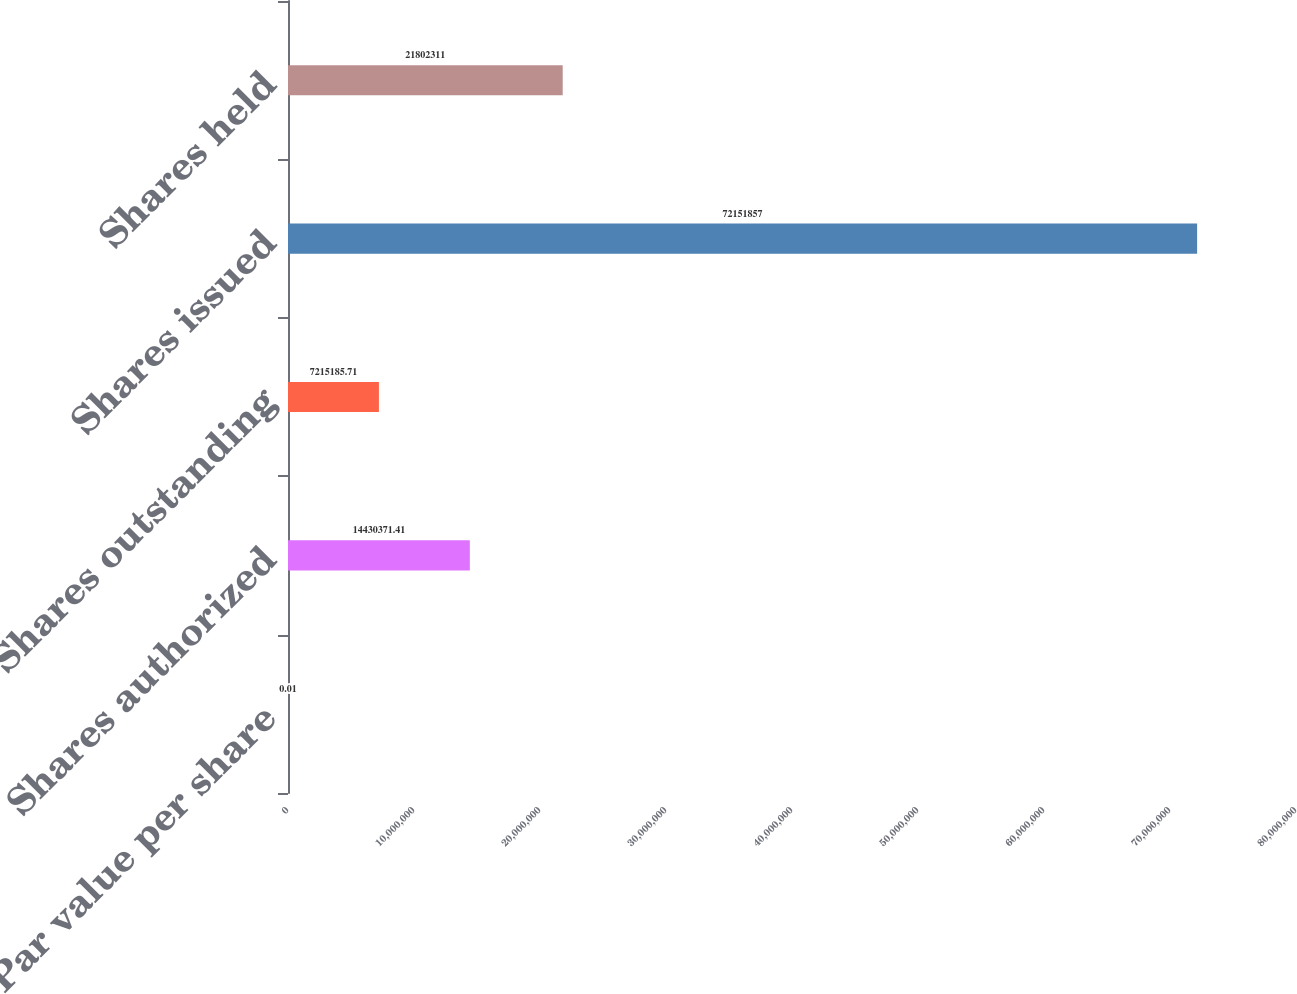Convert chart to OTSL. <chart><loc_0><loc_0><loc_500><loc_500><bar_chart><fcel>Par value per share<fcel>Shares authorized<fcel>Shares outstanding<fcel>Shares issued<fcel>Shares held<nl><fcel>0.01<fcel>1.44304e+07<fcel>7.21519e+06<fcel>7.21519e+07<fcel>2.18023e+07<nl></chart> 